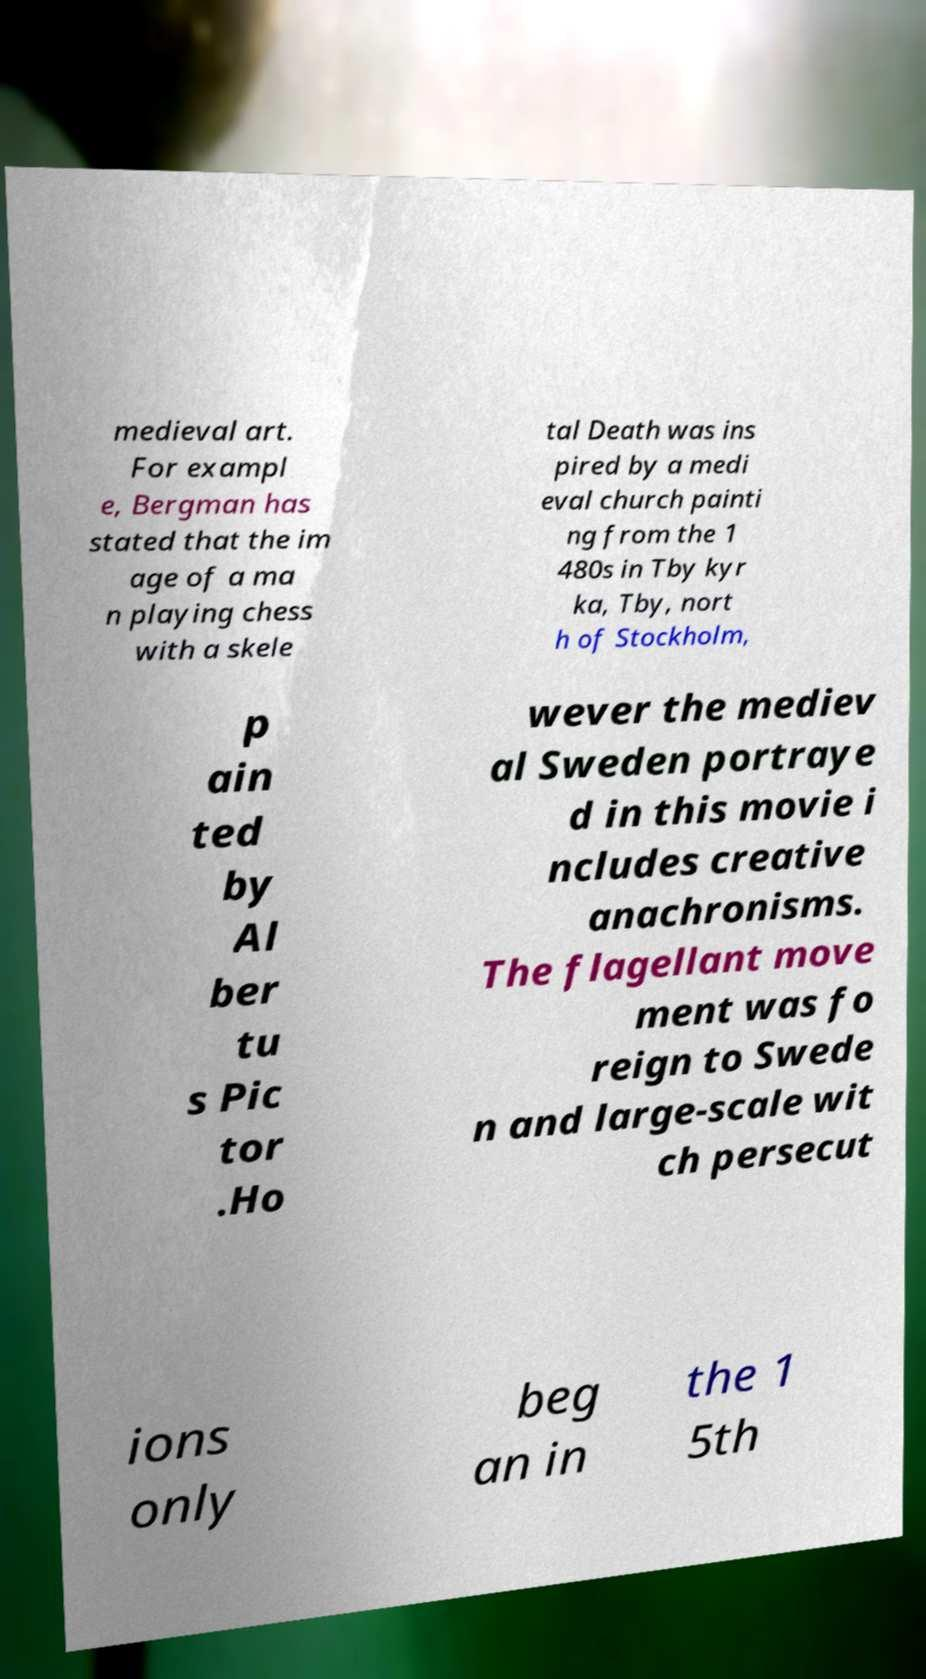I need the written content from this picture converted into text. Can you do that? medieval art. For exampl e, Bergman has stated that the im age of a ma n playing chess with a skele tal Death was ins pired by a medi eval church painti ng from the 1 480s in Tby kyr ka, Tby, nort h of Stockholm, p ain ted by Al ber tu s Pic tor .Ho wever the mediev al Sweden portraye d in this movie i ncludes creative anachronisms. The flagellant move ment was fo reign to Swede n and large-scale wit ch persecut ions only beg an in the 1 5th 